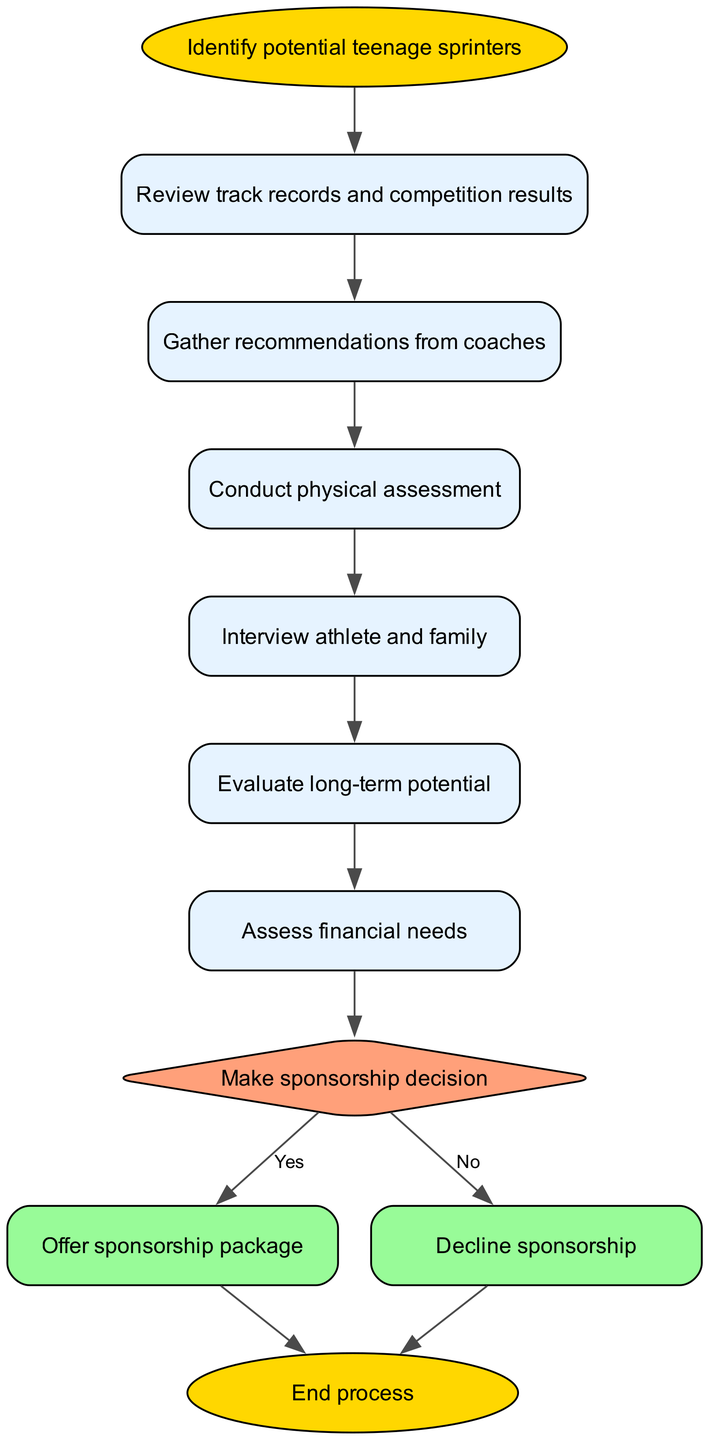What is the first step in the decision process? The first node in the flow chart is labeled "Identify potential teenage sprinters," indicating that this is the starting point of the decision-making process.
Answer: Identify potential teenage sprinters How many nodes are present in the flow chart? By counting all the different elements listed in the "elements" section, we find there are 11 nodes in total, including the start and end points.
Answer: 11 What decision follows the potential evaluation step? After the "Evaluate long-term potential" step, the next node is "Assess financial needs," indicating that this is the immediate action taken after the potential evaluation.
Answer: Assess financial needs What happens if the sponsorship decision is "No"? If the decision is "No," the flow chart indicates that the process moves to the "Decline sponsorship" node, meaning the sponsorship will not be offered.
Answer: Decline sponsorship What color represents the decision node in the diagram? The diamond-shaped decision node has a fill color of "#FFA07A," which distinguishes it visually from other nodes and indicates that it is a point of decision-making.
Answer: #FFA07A What is the final outcome of the diagram after offering sponsorship? The last step after "Offer sponsorship package" is to reach the "End process" node, signaling that the process is completed after the sponsorship is offered.
Answer: End process What step occurs immediately after gathering recommendations from coaches? The node following "Gather recommendations from coaches" is "Conduct physical assessment," indicating the next action taken in the process.
Answer: Conduct physical assessment What is assessed right before making the sponsorship decision? The flow chart shows that "Assess financial needs" is the step directly before the "Make sponsorship decision" node, making it a critical consideration at that stage.
Answer: Assess financial needs 